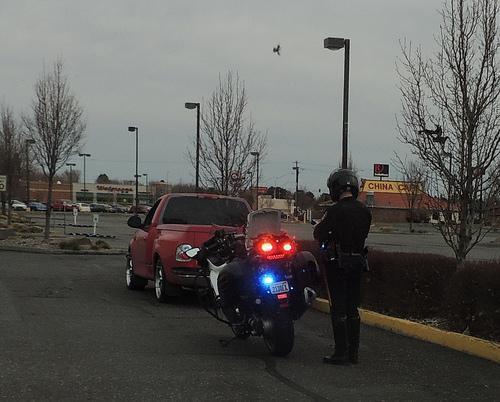How many people are pictured?
Give a very brief answer. 1. 